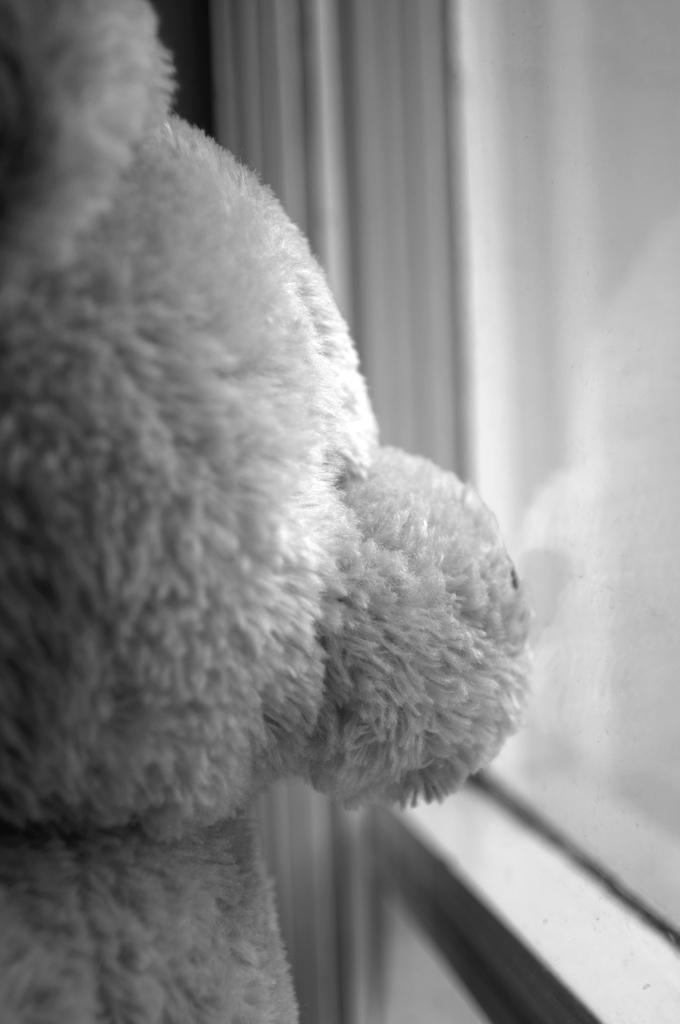What type of toy is present in the image? There is a teddy bear in the image. What architectural feature can be seen in the image? There is a window in the image. What is the condition of the rabbit in the image? There is no rabbit present in the image. What is the purpose of the teddy bear in the image? The purpose of the teddy bear in the image cannot be determined from the provided facts. 